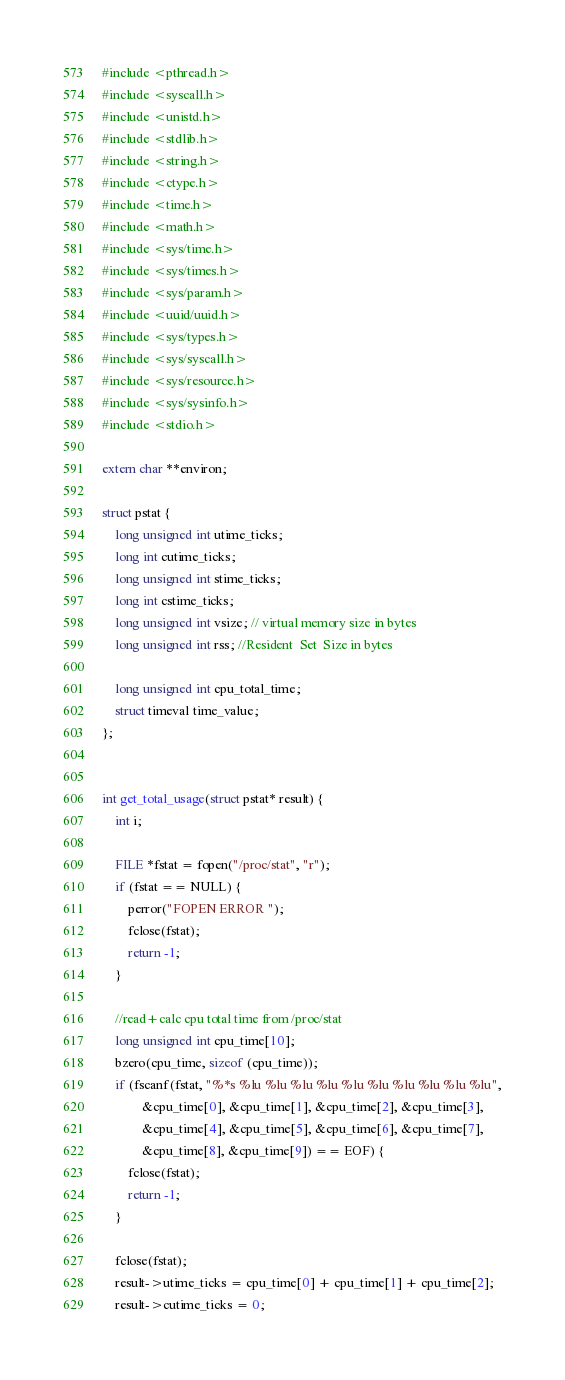<code> <loc_0><loc_0><loc_500><loc_500><_C_>#include <pthread.h>
#include <syscall.h>
#include <unistd.h>
#include <stdlib.h>
#include <string.h>
#include <ctype.h>
#include <time.h>
#include <math.h>
#include <sys/time.h>
#include <sys/times.h>
#include <sys/param.h>
#include <uuid/uuid.h>
#include <sys/types.h>
#include <sys/syscall.h>
#include <sys/resource.h>
#include <sys/sysinfo.h>
#include <stdio.h>

extern char **environ;

struct pstat {
    long unsigned int utime_ticks;
    long int cutime_ticks;
    long unsigned int stime_ticks;
    long int cstime_ticks;
    long unsigned int vsize; // virtual memory size in bytes
    long unsigned int rss; //Resident  Set  Size in bytes

    long unsigned int cpu_total_time;
    struct timeval time_value;
};


int get_total_usage(struct pstat* result) {
    int i;

    FILE *fstat = fopen("/proc/stat", "r");
    if (fstat == NULL) {
        perror("FOPEN ERROR ");
        fclose(fstat);
        return -1;
    }

    //read+calc cpu total time from /proc/stat
    long unsigned int cpu_time[10];
    bzero(cpu_time, sizeof (cpu_time));
    if (fscanf(fstat, "%*s %lu %lu %lu %lu %lu %lu %lu %lu %lu %lu",
            &cpu_time[0], &cpu_time[1], &cpu_time[2], &cpu_time[3],
            &cpu_time[4], &cpu_time[5], &cpu_time[6], &cpu_time[7],
            &cpu_time[8], &cpu_time[9]) == EOF) {
        fclose(fstat);
        return -1;
    }

    fclose(fstat);
    result->utime_ticks = cpu_time[0] + cpu_time[1] + cpu_time[2];
    result->cutime_ticks = 0;</code> 